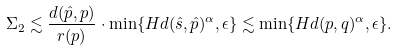Convert formula to latex. <formula><loc_0><loc_0><loc_500><loc_500>\Sigma _ { 2 } \lesssim \frac { d ( \hat { p } , p ) } { r ( p ) } \cdot \min \{ H d ( \hat { s } , \hat { p } ) ^ { \alpha } , \epsilon \} \lesssim \min \{ H d ( p , q ) ^ { \alpha } , \epsilon \} .</formula> 